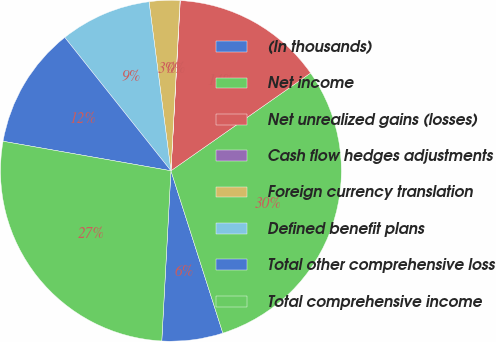Convert chart to OTSL. <chart><loc_0><loc_0><loc_500><loc_500><pie_chart><fcel>(In thousands)<fcel>Net income<fcel>Net unrealized gains (losses)<fcel>Cash flow hedges adjustments<fcel>Foreign currency translation<fcel>Defined benefit plans<fcel>Total other comprehensive loss<fcel>Total comprehensive income<nl><fcel>5.78%<fcel>29.79%<fcel>14.41%<fcel>0.02%<fcel>2.9%<fcel>8.65%<fcel>11.53%<fcel>26.91%<nl></chart> 